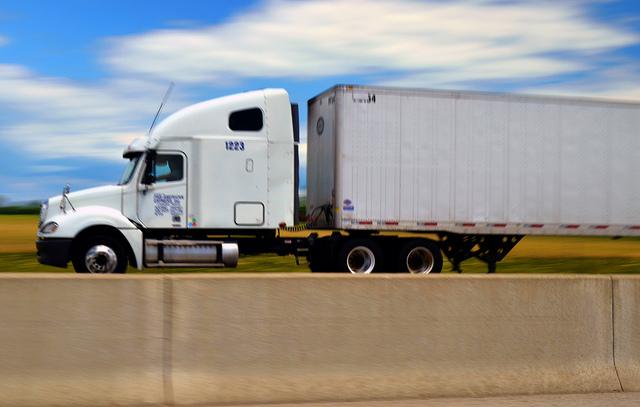What type of vehicle is this?
Be succinct. Truck. How many wheels?
Be succinct. 3. Is the truck in motion?
Give a very brief answer. Yes. 